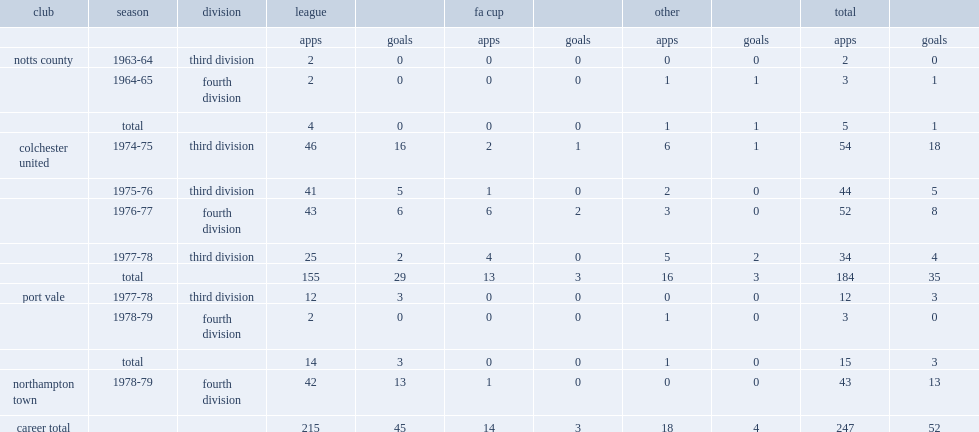How many league games in seve seasons did john froggatt play with 45 goals? 215.0. 